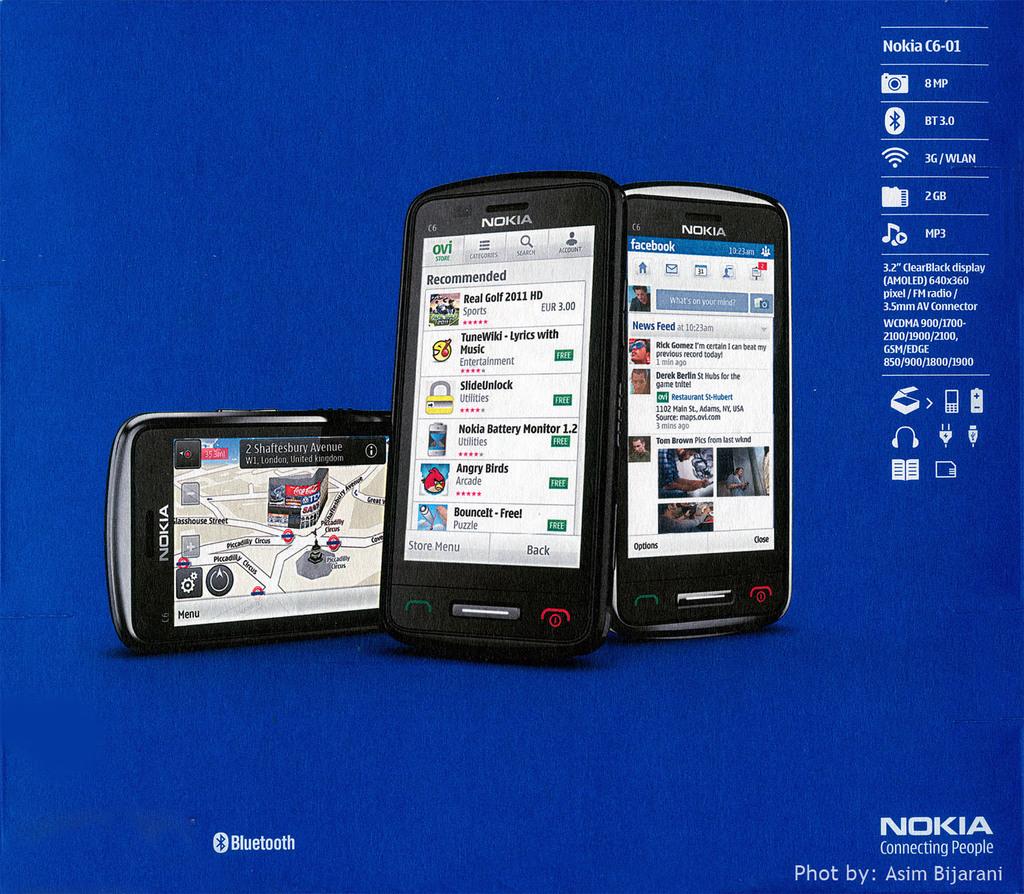Who is sponsoring this event?
Make the answer very short. Nokia. What model are the phones?
Your answer should be very brief. Nokia c6-01. 